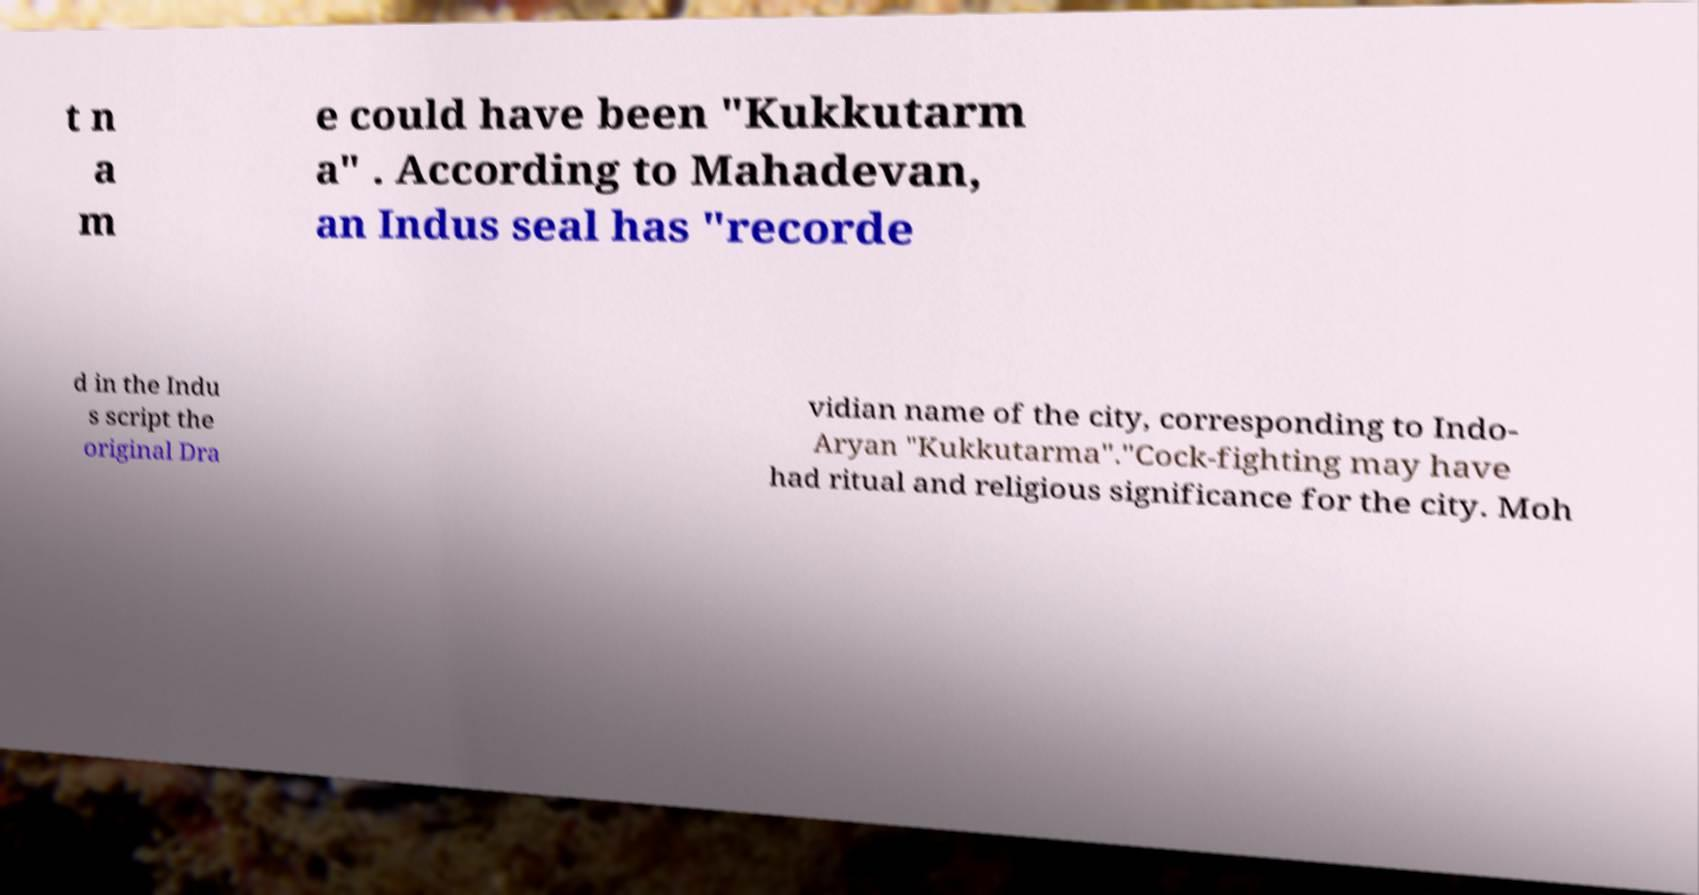What messages or text are displayed in this image? I need them in a readable, typed format. t n a m e could have been "Kukkutarm a" . According to Mahadevan, an Indus seal has "recorde d in the Indu s script the original Dra vidian name of the city, corresponding to Indo- Aryan "Kukkutarma"."Cock-fighting may have had ritual and religious significance for the city. Moh 